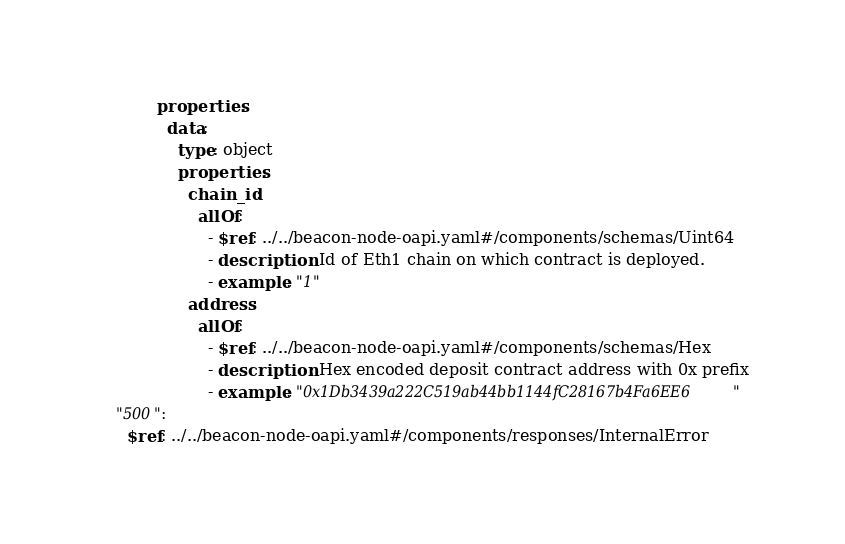Convert code to text. <code><loc_0><loc_0><loc_500><loc_500><_YAML_>            properties:
              data:
                type: object
                properties:
                  chain_id:
                    allOf:
                      - $ref: ../../beacon-node-oapi.yaml#/components/schemas/Uint64
                      - description: Id of Eth1 chain on which contract is deployed.
                      - example: "1"
                  address:
                    allOf:
                      - $ref: ../../beacon-node-oapi.yaml#/components/schemas/Hex
                      - description: Hex encoded deposit contract address with 0x prefix
                      - example: "0x1Db3439a222C519ab44bb1144fC28167b4Fa6EE6"
    "500":
      $ref: ../../beacon-node-oapi.yaml#/components/responses/InternalError
</code> 